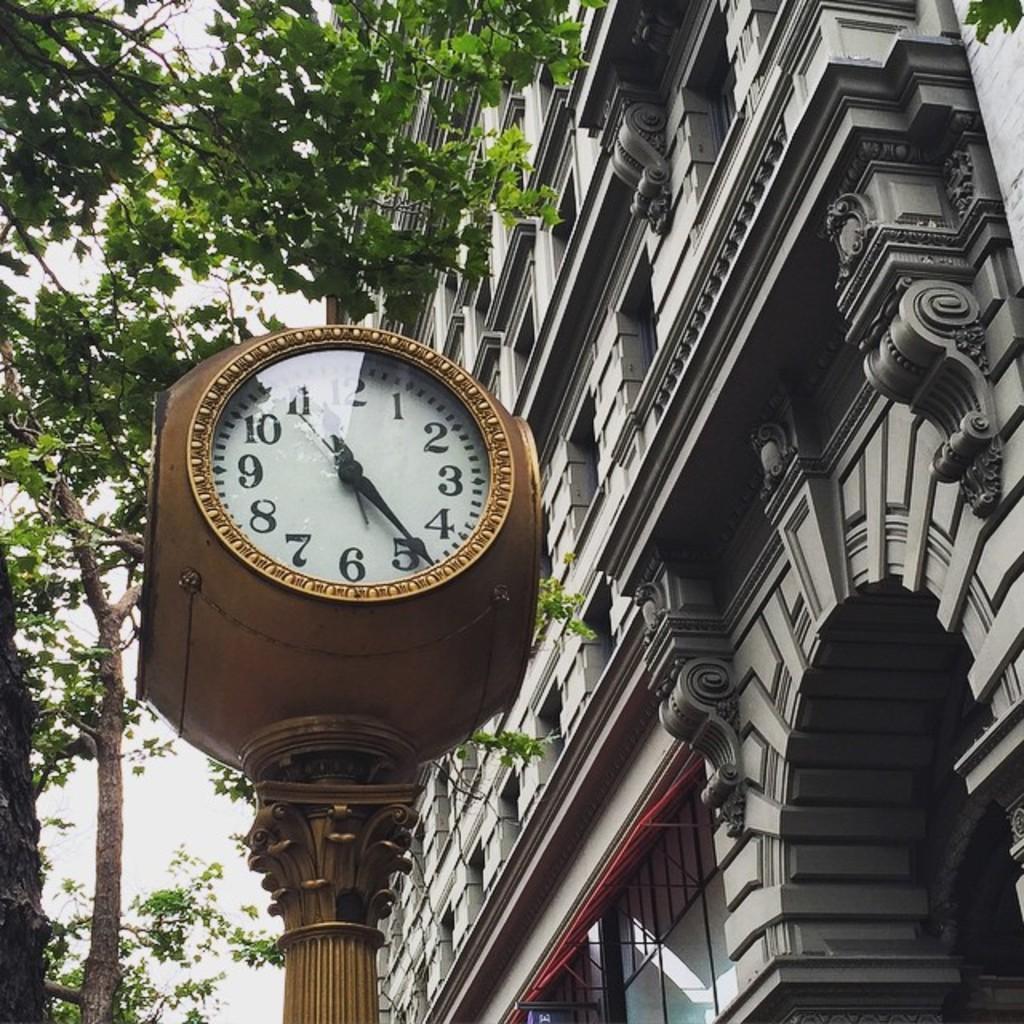Please provide a concise description of this image. In the middle it is a clock, on the left side there are trees. On the right side it is a building. 